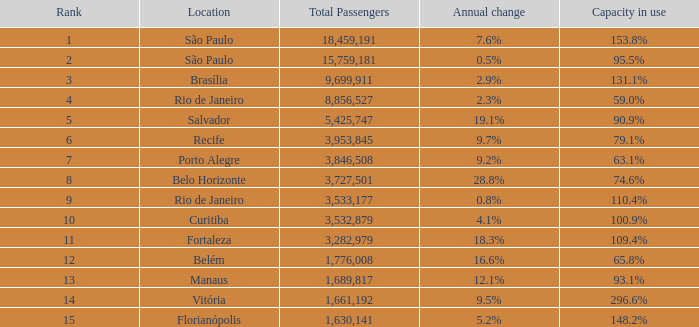When the annual change is 28.8% and the ranking is under 8, what is the sum of all passengers? 0.0. 